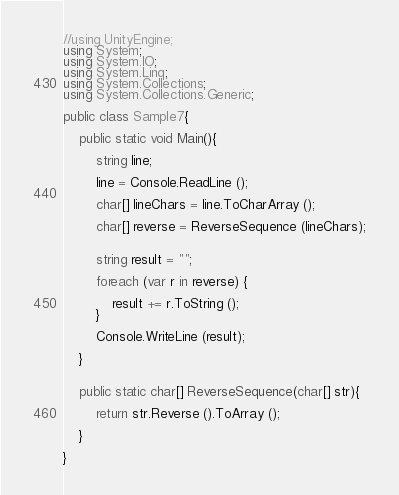Convert code to text. <code><loc_0><loc_0><loc_500><loc_500><_C#_>//using UnityEngine;
using System;
using System.IO;
using System.Linq;
using System.Collections;
using System.Collections.Generic;

public class Sample7{

	public static void Main(){

		string line;

		line = Console.ReadLine ();

		char[] lineChars = line.ToCharArray ();

		char[] reverse = ReverseSequence (lineChars);


		string result = "";

		foreach (var r in reverse) {

			result += r.ToString ();
		}

		Console.WriteLine (result);

	}


	public static char[] ReverseSequence(char[] str){

		return str.Reverse ().ToArray ();

	}

}</code> 